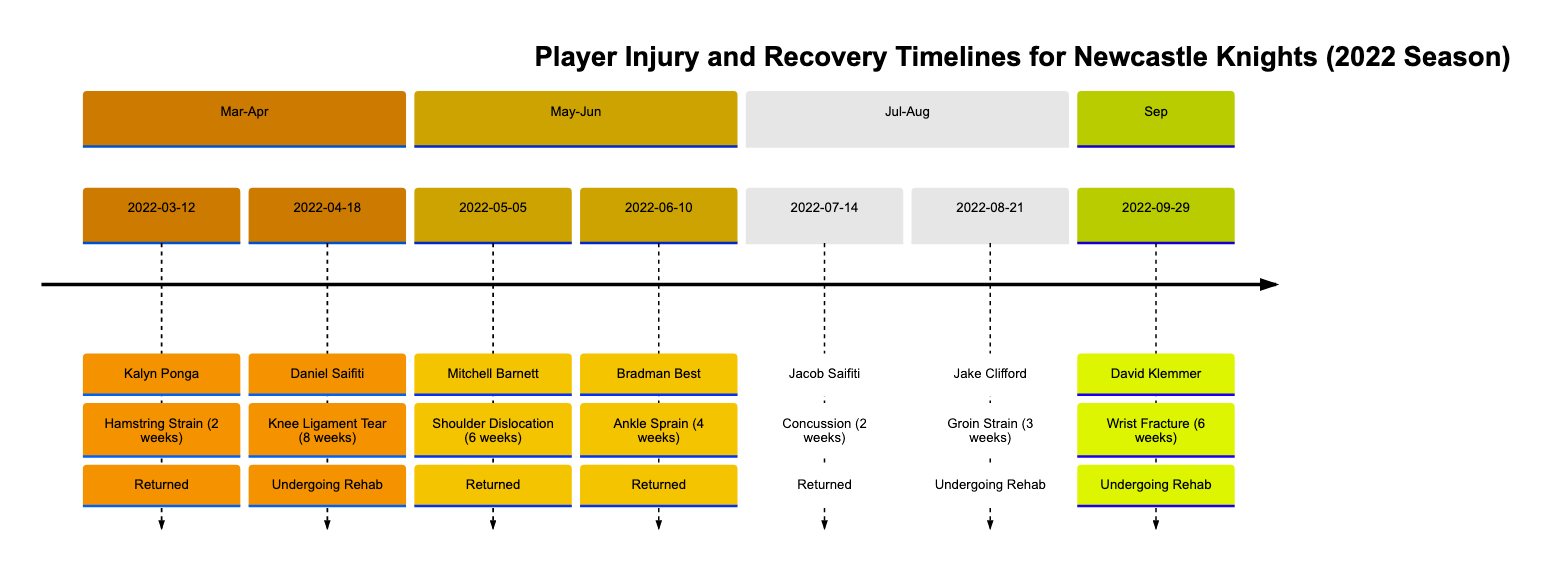What is the injury of Kalyn Ponga? According to the timeline, Kalyn Ponga's injury is listed as a Hamstring Strain.
Answer: Hamstring Strain When did Mitchell Barnett return from his injury? Mitchell Barnett returned on 2022-05-05, as indicated in the timeline, where his status shows as 'Returned'.
Answer: 2022-05-05 How long was Daniel Saifiti expected to be out due to his injury? Daniel Saifiti was expected to be out for 8 weeks due to a Knee Ligament Tear, as mentioned in the timeline next to his information.
Answer: 8 weeks How many players are currently undergoing rehab as of September 2022? In the timeline, two players (Daniel Saifiti and David Klemmer) are listed as 'Undergoing Rehab,' indicating they are still recovering from their injuries.
Answer: 2 What was the injury type of Jake Clifford? According to the timeline, Jake Clifford suffered from a Groin Strain, as stated next to his injury details.
Answer: Groin Strain Which player returned due to a concussion? The timeline shows that Jacob Saifiti returned from a concussion on 2022-07-14, marking his status as 'Returned.'
Answer: Jacob Saifiti What was the expected recovery time for Bradman Best? The expected recovery time for Bradman Best, according to the timeline, was 4 weeks due to an Ankle Sprain.
Answer: 4 weeks Which player had an injury on June 10, 2022? The timeline details that Bradman Best had an Ankle Sprain on June 10, 2022.
Answer: Bradman Best What is the last date listed in the timeline? The last entry in the timeline is dated 2022-09-29, where David Klemmer is reported with a Wrist Fracture.
Answer: 2022-09-29 